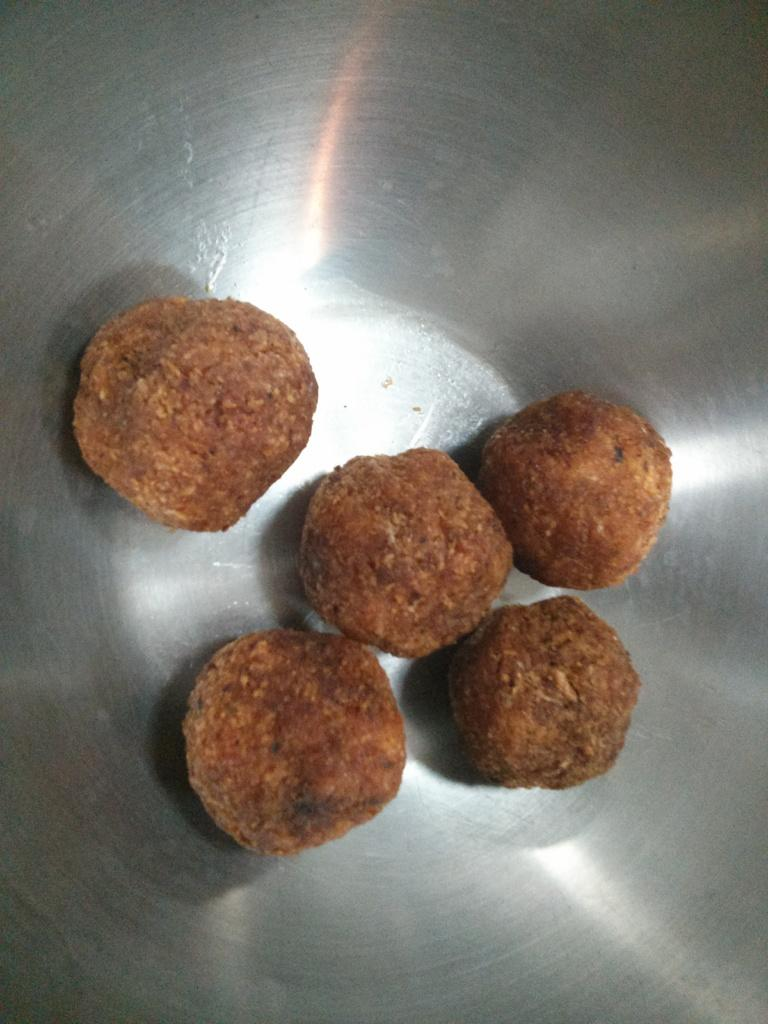What type of bowl is in the image? There is a steel bowl in the image. What is inside the bowl? There are five sweets in the bowl. What color is the curtain hanging behind the bowl in the image? There is no curtain present in the image. How does the brother of the person taking the picture feel about the sweets in the bowl? There is no information about a brother or their feelings in the image. 